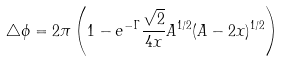<formula> <loc_0><loc_0><loc_500><loc_500>\triangle \phi = 2 \pi \left ( 1 - e ^ { - \Gamma } \frac { \sqrt { 2 } } { 4 x } A ^ { 1 / 2 } ( A - 2 x ) ^ { 1 / 2 } \right )</formula> 